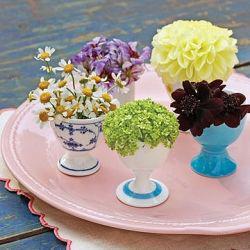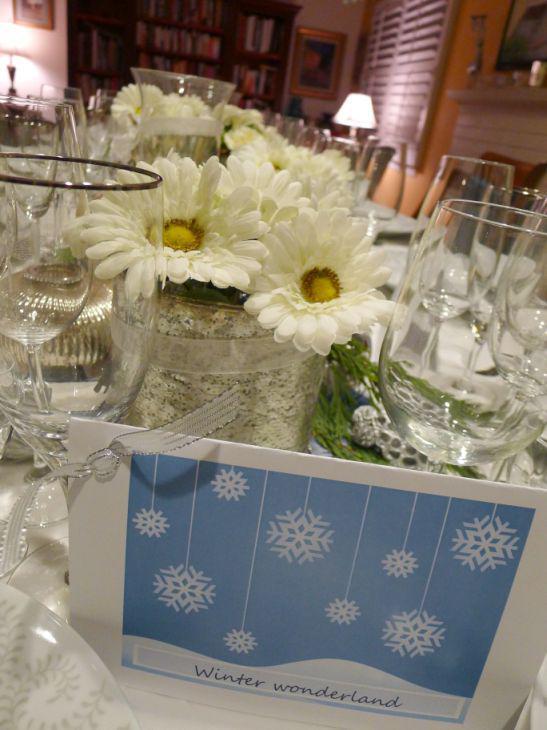The first image is the image on the left, the second image is the image on the right. Examine the images to the left and right. Is the description "At least one vase appears bright blue." accurate? Answer yes or no. Yes. 